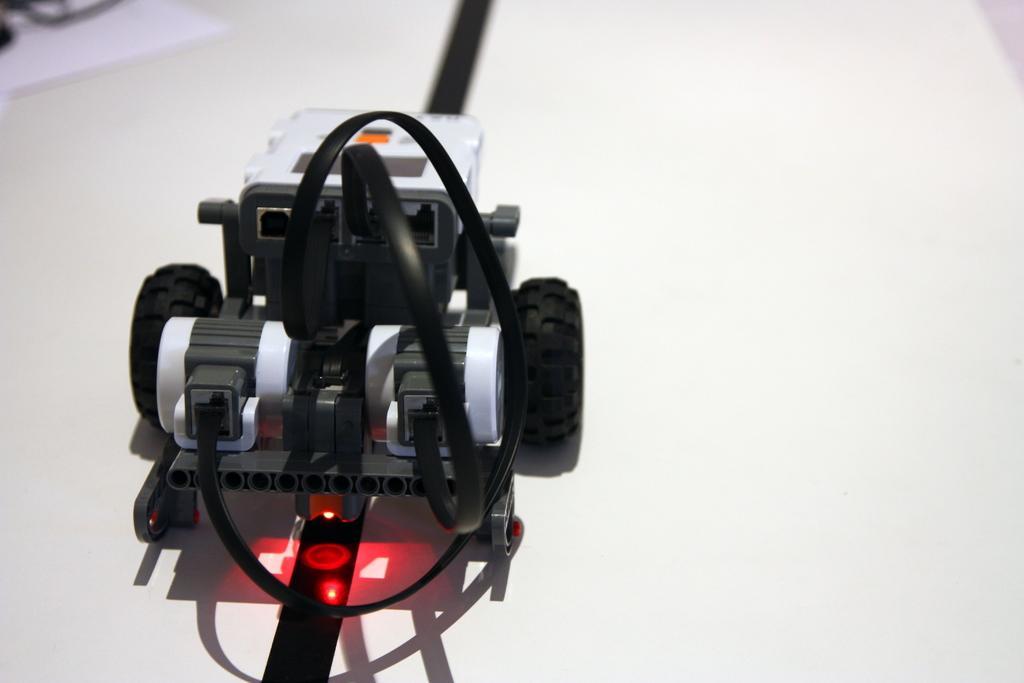Can you describe this image briefly? In this image I can see a toy car which is in black and white color and the car is on the white color surface. 